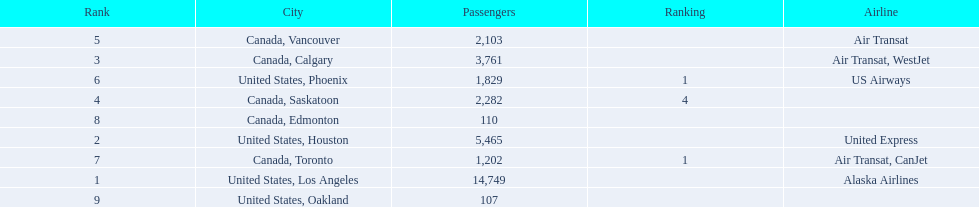Could you parse the entire table? {'header': ['Rank', 'City', 'Passengers', 'Ranking', 'Airline'], 'rows': [['5', 'Canada, Vancouver', '2,103', '', 'Air Transat'], ['3', 'Canada, Calgary', '3,761', '', 'Air Transat, WestJet'], ['6', 'United States, Phoenix', '1,829', '1', 'US Airways'], ['4', 'Canada, Saskatoon', '2,282', '4', ''], ['8', 'Canada, Edmonton', '110', '', ''], ['2', 'United States, Houston', '5,465', '', 'United Express'], ['7', 'Canada, Toronto', '1,202', '1', 'Air Transat, CanJet'], ['1', 'United States, Los Angeles', '14,749', '', 'Alaska Airlines'], ['9', 'United States, Oakland', '107', '', '']]} What are the cities that are associated with the playa de oro international airport? United States, Los Angeles, United States, Houston, Canada, Calgary, Canada, Saskatoon, Canada, Vancouver, United States, Phoenix, Canada, Toronto, Canada, Edmonton, United States, Oakland. What is uniteed states, los angeles passenger count? 14,749. What other cities passenger count would lead to 19,000 roughly when combined with previous los angeles? Canada, Calgary. 